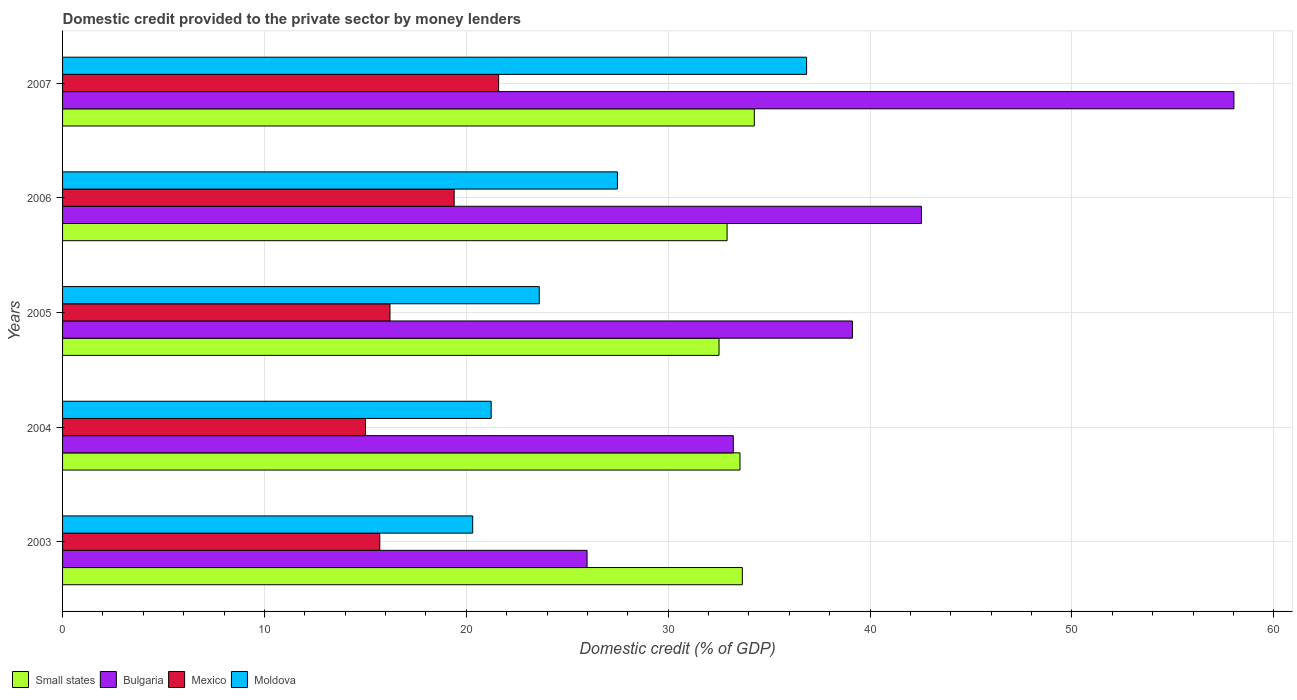How many different coloured bars are there?
Provide a succinct answer. 4. Are the number of bars on each tick of the Y-axis equal?
Your response must be concise. Yes. How many bars are there on the 5th tick from the top?
Ensure brevity in your answer.  4. What is the label of the 4th group of bars from the top?
Offer a terse response. 2004. What is the domestic credit provided to the private sector by money lenders in Moldova in 2004?
Ensure brevity in your answer.  21.23. Across all years, what is the maximum domestic credit provided to the private sector by money lenders in Moldova?
Keep it short and to the point. 36.86. Across all years, what is the minimum domestic credit provided to the private sector by money lenders in Mexico?
Offer a terse response. 15.01. In which year was the domestic credit provided to the private sector by money lenders in Mexico minimum?
Keep it short and to the point. 2004. What is the total domestic credit provided to the private sector by money lenders in Small states in the graph?
Offer a terse response. 166.93. What is the difference between the domestic credit provided to the private sector by money lenders in Bulgaria in 2003 and that in 2004?
Your answer should be very brief. -7.24. What is the difference between the domestic credit provided to the private sector by money lenders in Mexico in 2005 and the domestic credit provided to the private sector by money lenders in Bulgaria in 2003?
Keep it short and to the point. -9.76. What is the average domestic credit provided to the private sector by money lenders in Moldova per year?
Your answer should be compact. 25.9. In the year 2004, what is the difference between the domestic credit provided to the private sector by money lenders in Bulgaria and domestic credit provided to the private sector by money lenders in Small states?
Provide a short and direct response. -0.33. What is the ratio of the domestic credit provided to the private sector by money lenders in Bulgaria in 2004 to that in 2007?
Give a very brief answer. 0.57. Is the domestic credit provided to the private sector by money lenders in Bulgaria in 2003 less than that in 2007?
Provide a short and direct response. Yes. Is the difference between the domestic credit provided to the private sector by money lenders in Bulgaria in 2003 and 2006 greater than the difference between the domestic credit provided to the private sector by money lenders in Small states in 2003 and 2006?
Ensure brevity in your answer.  No. What is the difference between the highest and the second highest domestic credit provided to the private sector by money lenders in Bulgaria?
Offer a very short reply. 15.48. What is the difference between the highest and the lowest domestic credit provided to the private sector by money lenders in Bulgaria?
Offer a terse response. 32.04. In how many years, is the domestic credit provided to the private sector by money lenders in Moldova greater than the average domestic credit provided to the private sector by money lenders in Moldova taken over all years?
Your response must be concise. 2. Is it the case that in every year, the sum of the domestic credit provided to the private sector by money lenders in Mexico and domestic credit provided to the private sector by money lenders in Bulgaria is greater than the sum of domestic credit provided to the private sector by money lenders in Small states and domestic credit provided to the private sector by money lenders in Moldova?
Provide a succinct answer. No. What does the 3rd bar from the top in 2003 represents?
Make the answer very short. Bulgaria. What does the 2nd bar from the bottom in 2005 represents?
Your response must be concise. Bulgaria. Is it the case that in every year, the sum of the domestic credit provided to the private sector by money lenders in Bulgaria and domestic credit provided to the private sector by money lenders in Mexico is greater than the domestic credit provided to the private sector by money lenders in Moldova?
Keep it short and to the point. Yes. How many bars are there?
Give a very brief answer. 20. How many years are there in the graph?
Your answer should be very brief. 5. Does the graph contain any zero values?
Offer a terse response. No. Does the graph contain grids?
Make the answer very short. Yes. Where does the legend appear in the graph?
Provide a short and direct response. Bottom left. How many legend labels are there?
Your response must be concise. 4. How are the legend labels stacked?
Give a very brief answer. Horizontal. What is the title of the graph?
Give a very brief answer. Domestic credit provided to the private sector by money lenders. Does "World" appear as one of the legend labels in the graph?
Make the answer very short. No. What is the label or title of the X-axis?
Offer a very short reply. Domestic credit (% of GDP). What is the label or title of the Y-axis?
Your answer should be very brief. Years. What is the Domestic credit (% of GDP) of Small states in 2003?
Your response must be concise. 33.67. What is the Domestic credit (% of GDP) of Bulgaria in 2003?
Your answer should be very brief. 25.98. What is the Domestic credit (% of GDP) in Mexico in 2003?
Give a very brief answer. 15.71. What is the Domestic credit (% of GDP) in Moldova in 2003?
Provide a succinct answer. 20.32. What is the Domestic credit (% of GDP) in Small states in 2004?
Your answer should be compact. 33.56. What is the Domestic credit (% of GDP) in Bulgaria in 2004?
Provide a short and direct response. 33.23. What is the Domestic credit (% of GDP) of Mexico in 2004?
Ensure brevity in your answer.  15.01. What is the Domestic credit (% of GDP) in Moldova in 2004?
Keep it short and to the point. 21.23. What is the Domestic credit (% of GDP) of Small states in 2005?
Provide a succinct answer. 32.52. What is the Domestic credit (% of GDP) of Bulgaria in 2005?
Offer a terse response. 39.13. What is the Domestic credit (% of GDP) of Mexico in 2005?
Your answer should be very brief. 16.22. What is the Domestic credit (% of GDP) in Moldova in 2005?
Make the answer very short. 23.61. What is the Domestic credit (% of GDP) in Small states in 2006?
Offer a very short reply. 32.92. What is the Domestic credit (% of GDP) of Bulgaria in 2006?
Offer a terse response. 42.54. What is the Domestic credit (% of GDP) in Mexico in 2006?
Make the answer very short. 19.4. What is the Domestic credit (% of GDP) of Moldova in 2006?
Ensure brevity in your answer.  27.48. What is the Domestic credit (% of GDP) of Small states in 2007?
Keep it short and to the point. 34.27. What is the Domestic credit (% of GDP) in Bulgaria in 2007?
Ensure brevity in your answer.  58.02. What is the Domestic credit (% of GDP) of Mexico in 2007?
Make the answer very short. 21.6. What is the Domestic credit (% of GDP) in Moldova in 2007?
Ensure brevity in your answer.  36.86. Across all years, what is the maximum Domestic credit (% of GDP) of Small states?
Your answer should be very brief. 34.27. Across all years, what is the maximum Domestic credit (% of GDP) in Bulgaria?
Offer a terse response. 58.02. Across all years, what is the maximum Domestic credit (% of GDP) in Mexico?
Make the answer very short. 21.6. Across all years, what is the maximum Domestic credit (% of GDP) of Moldova?
Provide a succinct answer. 36.86. Across all years, what is the minimum Domestic credit (% of GDP) of Small states?
Offer a very short reply. 32.52. Across all years, what is the minimum Domestic credit (% of GDP) in Bulgaria?
Give a very brief answer. 25.98. Across all years, what is the minimum Domestic credit (% of GDP) of Mexico?
Make the answer very short. 15.01. Across all years, what is the minimum Domestic credit (% of GDP) of Moldova?
Provide a succinct answer. 20.32. What is the total Domestic credit (% of GDP) of Small states in the graph?
Your response must be concise. 166.93. What is the total Domestic credit (% of GDP) of Bulgaria in the graph?
Your answer should be very brief. 198.9. What is the total Domestic credit (% of GDP) of Mexico in the graph?
Your response must be concise. 87.94. What is the total Domestic credit (% of GDP) of Moldova in the graph?
Keep it short and to the point. 129.5. What is the difference between the Domestic credit (% of GDP) of Small states in 2003 and that in 2004?
Ensure brevity in your answer.  0.12. What is the difference between the Domestic credit (% of GDP) in Bulgaria in 2003 and that in 2004?
Your answer should be compact. -7.24. What is the difference between the Domestic credit (% of GDP) in Mexico in 2003 and that in 2004?
Your response must be concise. 0.71. What is the difference between the Domestic credit (% of GDP) of Moldova in 2003 and that in 2004?
Offer a terse response. -0.91. What is the difference between the Domestic credit (% of GDP) of Small states in 2003 and that in 2005?
Offer a terse response. 1.15. What is the difference between the Domestic credit (% of GDP) of Bulgaria in 2003 and that in 2005?
Your answer should be compact. -13.14. What is the difference between the Domestic credit (% of GDP) in Mexico in 2003 and that in 2005?
Offer a terse response. -0.5. What is the difference between the Domestic credit (% of GDP) in Moldova in 2003 and that in 2005?
Your response must be concise. -3.3. What is the difference between the Domestic credit (% of GDP) of Small states in 2003 and that in 2006?
Offer a very short reply. 0.76. What is the difference between the Domestic credit (% of GDP) in Bulgaria in 2003 and that in 2006?
Your answer should be compact. -16.56. What is the difference between the Domestic credit (% of GDP) of Mexico in 2003 and that in 2006?
Provide a short and direct response. -3.68. What is the difference between the Domestic credit (% of GDP) in Moldova in 2003 and that in 2006?
Provide a short and direct response. -7.17. What is the difference between the Domestic credit (% of GDP) in Small states in 2003 and that in 2007?
Keep it short and to the point. -0.59. What is the difference between the Domestic credit (% of GDP) in Bulgaria in 2003 and that in 2007?
Provide a short and direct response. -32.04. What is the difference between the Domestic credit (% of GDP) in Mexico in 2003 and that in 2007?
Offer a terse response. -5.89. What is the difference between the Domestic credit (% of GDP) in Moldova in 2003 and that in 2007?
Offer a terse response. -16.54. What is the difference between the Domestic credit (% of GDP) of Small states in 2004 and that in 2005?
Make the answer very short. 1.04. What is the difference between the Domestic credit (% of GDP) in Bulgaria in 2004 and that in 2005?
Make the answer very short. -5.9. What is the difference between the Domestic credit (% of GDP) of Mexico in 2004 and that in 2005?
Give a very brief answer. -1.21. What is the difference between the Domestic credit (% of GDP) of Moldova in 2004 and that in 2005?
Ensure brevity in your answer.  -2.38. What is the difference between the Domestic credit (% of GDP) of Small states in 2004 and that in 2006?
Keep it short and to the point. 0.64. What is the difference between the Domestic credit (% of GDP) in Bulgaria in 2004 and that in 2006?
Your answer should be very brief. -9.32. What is the difference between the Domestic credit (% of GDP) of Mexico in 2004 and that in 2006?
Your answer should be compact. -4.39. What is the difference between the Domestic credit (% of GDP) of Moldova in 2004 and that in 2006?
Give a very brief answer. -6.25. What is the difference between the Domestic credit (% of GDP) in Small states in 2004 and that in 2007?
Ensure brevity in your answer.  -0.71. What is the difference between the Domestic credit (% of GDP) of Bulgaria in 2004 and that in 2007?
Ensure brevity in your answer.  -24.8. What is the difference between the Domestic credit (% of GDP) of Mexico in 2004 and that in 2007?
Provide a short and direct response. -6.59. What is the difference between the Domestic credit (% of GDP) in Moldova in 2004 and that in 2007?
Provide a succinct answer. -15.62. What is the difference between the Domestic credit (% of GDP) in Small states in 2005 and that in 2006?
Give a very brief answer. -0.4. What is the difference between the Domestic credit (% of GDP) of Bulgaria in 2005 and that in 2006?
Provide a short and direct response. -3.42. What is the difference between the Domestic credit (% of GDP) in Mexico in 2005 and that in 2006?
Provide a succinct answer. -3.18. What is the difference between the Domestic credit (% of GDP) of Moldova in 2005 and that in 2006?
Keep it short and to the point. -3.87. What is the difference between the Domestic credit (% of GDP) of Small states in 2005 and that in 2007?
Keep it short and to the point. -1.75. What is the difference between the Domestic credit (% of GDP) in Bulgaria in 2005 and that in 2007?
Provide a short and direct response. -18.9. What is the difference between the Domestic credit (% of GDP) of Mexico in 2005 and that in 2007?
Make the answer very short. -5.38. What is the difference between the Domestic credit (% of GDP) in Moldova in 2005 and that in 2007?
Your answer should be compact. -13.24. What is the difference between the Domestic credit (% of GDP) of Small states in 2006 and that in 2007?
Your answer should be very brief. -1.35. What is the difference between the Domestic credit (% of GDP) in Bulgaria in 2006 and that in 2007?
Give a very brief answer. -15.48. What is the difference between the Domestic credit (% of GDP) in Mexico in 2006 and that in 2007?
Give a very brief answer. -2.2. What is the difference between the Domestic credit (% of GDP) in Moldova in 2006 and that in 2007?
Offer a very short reply. -9.37. What is the difference between the Domestic credit (% of GDP) in Small states in 2003 and the Domestic credit (% of GDP) in Bulgaria in 2004?
Your answer should be compact. 0.45. What is the difference between the Domestic credit (% of GDP) in Small states in 2003 and the Domestic credit (% of GDP) in Mexico in 2004?
Provide a succinct answer. 18.67. What is the difference between the Domestic credit (% of GDP) in Small states in 2003 and the Domestic credit (% of GDP) in Moldova in 2004?
Provide a short and direct response. 12.44. What is the difference between the Domestic credit (% of GDP) in Bulgaria in 2003 and the Domestic credit (% of GDP) in Mexico in 2004?
Your answer should be compact. 10.98. What is the difference between the Domestic credit (% of GDP) of Bulgaria in 2003 and the Domestic credit (% of GDP) of Moldova in 2004?
Provide a short and direct response. 4.75. What is the difference between the Domestic credit (% of GDP) in Mexico in 2003 and the Domestic credit (% of GDP) in Moldova in 2004?
Your answer should be very brief. -5.52. What is the difference between the Domestic credit (% of GDP) of Small states in 2003 and the Domestic credit (% of GDP) of Bulgaria in 2005?
Keep it short and to the point. -5.45. What is the difference between the Domestic credit (% of GDP) of Small states in 2003 and the Domestic credit (% of GDP) of Mexico in 2005?
Keep it short and to the point. 17.45. What is the difference between the Domestic credit (% of GDP) of Small states in 2003 and the Domestic credit (% of GDP) of Moldova in 2005?
Your answer should be compact. 10.06. What is the difference between the Domestic credit (% of GDP) of Bulgaria in 2003 and the Domestic credit (% of GDP) of Mexico in 2005?
Ensure brevity in your answer.  9.76. What is the difference between the Domestic credit (% of GDP) of Bulgaria in 2003 and the Domestic credit (% of GDP) of Moldova in 2005?
Provide a short and direct response. 2.37. What is the difference between the Domestic credit (% of GDP) of Mexico in 2003 and the Domestic credit (% of GDP) of Moldova in 2005?
Keep it short and to the point. -7.9. What is the difference between the Domestic credit (% of GDP) of Small states in 2003 and the Domestic credit (% of GDP) of Bulgaria in 2006?
Keep it short and to the point. -8.87. What is the difference between the Domestic credit (% of GDP) of Small states in 2003 and the Domestic credit (% of GDP) of Mexico in 2006?
Provide a succinct answer. 14.28. What is the difference between the Domestic credit (% of GDP) in Small states in 2003 and the Domestic credit (% of GDP) in Moldova in 2006?
Make the answer very short. 6.19. What is the difference between the Domestic credit (% of GDP) of Bulgaria in 2003 and the Domestic credit (% of GDP) of Mexico in 2006?
Offer a terse response. 6.58. What is the difference between the Domestic credit (% of GDP) of Bulgaria in 2003 and the Domestic credit (% of GDP) of Moldova in 2006?
Your answer should be very brief. -1.5. What is the difference between the Domestic credit (% of GDP) in Mexico in 2003 and the Domestic credit (% of GDP) in Moldova in 2006?
Your response must be concise. -11.77. What is the difference between the Domestic credit (% of GDP) in Small states in 2003 and the Domestic credit (% of GDP) in Bulgaria in 2007?
Offer a very short reply. -24.35. What is the difference between the Domestic credit (% of GDP) of Small states in 2003 and the Domestic credit (% of GDP) of Mexico in 2007?
Your answer should be compact. 12.07. What is the difference between the Domestic credit (% of GDP) in Small states in 2003 and the Domestic credit (% of GDP) in Moldova in 2007?
Keep it short and to the point. -3.18. What is the difference between the Domestic credit (% of GDP) of Bulgaria in 2003 and the Domestic credit (% of GDP) of Mexico in 2007?
Your response must be concise. 4.38. What is the difference between the Domestic credit (% of GDP) of Bulgaria in 2003 and the Domestic credit (% of GDP) of Moldova in 2007?
Offer a terse response. -10.87. What is the difference between the Domestic credit (% of GDP) of Mexico in 2003 and the Domestic credit (% of GDP) of Moldova in 2007?
Provide a succinct answer. -21.14. What is the difference between the Domestic credit (% of GDP) of Small states in 2004 and the Domestic credit (% of GDP) of Bulgaria in 2005?
Provide a short and direct response. -5.57. What is the difference between the Domestic credit (% of GDP) of Small states in 2004 and the Domestic credit (% of GDP) of Mexico in 2005?
Your answer should be very brief. 17.34. What is the difference between the Domestic credit (% of GDP) of Small states in 2004 and the Domestic credit (% of GDP) of Moldova in 2005?
Provide a succinct answer. 9.94. What is the difference between the Domestic credit (% of GDP) of Bulgaria in 2004 and the Domestic credit (% of GDP) of Mexico in 2005?
Ensure brevity in your answer.  17.01. What is the difference between the Domestic credit (% of GDP) in Bulgaria in 2004 and the Domestic credit (% of GDP) in Moldova in 2005?
Your answer should be very brief. 9.61. What is the difference between the Domestic credit (% of GDP) in Mexico in 2004 and the Domestic credit (% of GDP) in Moldova in 2005?
Provide a succinct answer. -8.61. What is the difference between the Domestic credit (% of GDP) of Small states in 2004 and the Domestic credit (% of GDP) of Bulgaria in 2006?
Offer a very short reply. -8.99. What is the difference between the Domestic credit (% of GDP) in Small states in 2004 and the Domestic credit (% of GDP) in Mexico in 2006?
Give a very brief answer. 14.16. What is the difference between the Domestic credit (% of GDP) of Small states in 2004 and the Domestic credit (% of GDP) of Moldova in 2006?
Your response must be concise. 6.07. What is the difference between the Domestic credit (% of GDP) of Bulgaria in 2004 and the Domestic credit (% of GDP) of Mexico in 2006?
Keep it short and to the point. 13.83. What is the difference between the Domestic credit (% of GDP) of Bulgaria in 2004 and the Domestic credit (% of GDP) of Moldova in 2006?
Provide a short and direct response. 5.74. What is the difference between the Domestic credit (% of GDP) in Mexico in 2004 and the Domestic credit (% of GDP) in Moldova in 2006?
Your response must be concise. -12.48. What is the difference between the Domestic credit (% of GDP) of Small states in 2004 and the Domestic credit (% of GDP) of Bulgaria in 2007?
Make the answer very short. -24.47. What is the difference between the Domestic credit (% of GDP) of Small states in 2004 and the Domestic credit (% of GDP) of Mexico in 2007?
Provide a succinct answer. 11.96. What is the difference between the Domestic credit (% of GDP) in Small states in 2004 and the Domestic credit (% of GDP) in Moldova in 2007?
Your answer should be compact. -3.3. What is the difference between the Domestic credit (% of GDP) in Bulgaria in 2004 and the Domestic credit (% of GDP) in Mexico in 2007?
Give a very brief answer. 11.62. What is the difference between the Domestic credit (% of GDP) in Bulgaria in 2004 and the Domestic credit (% of GDP) in Moldova in 2007?
Offer a terse response. -3.63. What is the difference between the Domestic credit (% of GDP) of Mexico in 2004 and the Domestic credit (% of GDP) of Moldova in 2007?
Provide a short and direct response. -21.85. What is the difference between the Domestic credit (% of GDP) in Small states in 2005 and the Domestic credit (% of GDP) in Bulgaria in 2006?
Make the answer very short. -10.03. What is the difference between the Domestic credit (% of GDP) of Small states in 2005 and the Domestic credit (% of GDP) of Mexico in 2006?
Provide a succinct answer. 13.12. What is the difference between the Domestic credit (% of GDP) in Small states in 2005 and the Domestic credit (% of GDP) in Moldova in 2006?
Give a very brief answer. 5.03. What is the difference between the Domestic credit (% of GDP) in Bulgaria in 2005 and the Domestic credit (% of GDP) in Mexico in 2006?
Provide a succinct answer. 19.73. What is the difference between the Domestic credit (% of GDP) of Bulgaria in 2005 and the Domestic credit (% of GDP) of Moldova in 2006?
Your answer should be very brief. 11.64. What is the difference between the Domestic credit (% of GDP) of Mexico in 2005 and the Domestic credit (% of GDP) of Moldova in 2006?
Provide a short and direct response. -11.27. What is the difference between the Domestic credit (% of GDP) of Small states in 2005 and the Domestic credit (% of GDP) of Bulgaria in 2007?
Give a very brief answer. -25.51. What is the difference between the Domestic credit (% of GDP) of Small states in 2005 and the Domestic credit (% of GDP) of Mexico in 2007?
Your answer should be very brief. 10.92. What is the difference between the Domestic credit (% of GDP) in Small states in 2005 and the Domestic credit (% of GDP) in Moldova in 2007?
Offer a terse response. -4.34. What is the difference between the Domestic credit (% of GDP) in Bulgaria in 2005 and the Domestic credit (% of GDP) in Mexico in 2007?
Provide a short and direct response. 17.53. What is the difference between the Domestic credit (% of GDP) of Bulgaria in 2005 and the Domestic credit (% of GDP) of Moldova in 2007?
Your answer should be very brief. 2.27. What is the difference between the Domestic credit (% of GDP) in Mexico in 2005 and the Domestic credit (% of GDP) in Moldova in 2007?
Provide a short and direct response. -20.64. What is the difference between the Domestic credit (% of GDP) of Small states in 2006 and the Domestic credit (% of GDP) of Bulgaria in 2007?
Provide a succinct answer. -25.11. What is the difference between the Domestic credit (% of GDP) of Small states in 2006 and the Domestic credit (% of GDP) of Mexico in 2007?
Offer a terse response. 11.32. What is the difference between the Domestic credit (% of GDP) in Small states in 2006 and the Domestic credit (% of GDP) in Moldova in 2007?
Provide a short and direct response. -3.94. What is the difference between the Domestic credit (% of GDP) of Bulgaria in 2006 and the Domestic credit (% of GDP) of Mexico in 2007?
Provide a succinct answer. 20.94. What is the difference between the Domestic credit (% of GDP) of Bulgaria in 2006 and the Domestic credit (% of GDP) of Moldova in 2007?
Your answer should be very brief. 5.69. What is the difference between the Domestic credit (% of GDP) of Mexico in 2006 and the Domestic credit (% of GDP) of Moldova in 2007?
Offer a terse response. -17.46. What is the average Domestic credit (% of GDP) of Small states per year?
Keep it short and to the point. 33.39. What is the average Domestic credit (% of GDP) of Bulgaria per year?
Offer a terse response. 39.78. What is the average Domestic credit (% of GDP) of Mexico per year?
Provide a short and direct response. 17.59. What is the average Domestic credit (% of GDP) in Moldova per year?
Keep it short and to the point. 25.9. In the year 2003, what is the difference between the Domestic credit (% of GDP) in Small states and Domestic credit (% of GDP) in Bulgaria?
Your answer should be compact. 7.69. In the year 2003, what is the difference between the Domestic credit (% of GDP) of Small states and Domestic credit (% of GDP) of Mexico?
Offer a terse response. 17.96. In the year 2003, what is the difference between the Domestic credit (% of GDP) of Small states and Domestic credit (% of GDP) of Moldova?
Provide a short and direct response. 13.36. In the year 2003, what is the difference between the Domestic credit (% of GDP) in Bulgaria and Domestic credit (% of GDP) in Mexico?
Ensure brevity in your answer.  10.27. In the year 2003, what is the difference between the Domestic credit (% of GDP) of Bulgaria and Domestic credit (% of GDP) of Moldova?
Your answer should be very brief. 5.67. In the year 2003, what is the difference between the Domestic credit (% of GDP) in Mexico and Domestic credit (% of GDP) in Moldova?
Offer a terse response. -4.6. In the year 2004, what is the difference between the Domestic credit (% of GDP) of Small states and Domestic credit (% of GDP) of Bulgaria?
Keep it short and to the point. 0.33. In the year 2004, what is the difference between the Domestic credit (% of GDP) of Small states and Domestic credit (% of GDP) of Mexico?
Keep it short and to the point. 18.55. In the year 2004, what is the difference between the Domestic credit (% of GDP) in Small states and Domestic credit (% of GDP) in Moldova?
Ensure brevity in your answer.  12.33. In the year 2004, what is the difference between the Domestic credit (% of GDP) in Bulgaria and Domestic credit (% of GDP) in Mexico?
Your response must be concise. 18.22. In the year 2004, what is the difference between the Domestic credit (% of GDP) of Bulgaria and Domestic credit (% of GDP) of Moldova?
Your answer should be compact. 11.99. In the year 2004, what is the difference between the Domestic credit (% of GDP) in Mexico and Domestic credit (% of GDP) in Moldova?
Your answer should be compact. -6.22. In the year 2005, what is the difference between the Domestic credit (% of GDP) of Small states and Domestic credit (% of GDP) of Bulgaria?
Your response must be concise. -6.61. In the year 2005, what is the difference between the Domestic credit (% of GDP) in Small states and Domestic credit (% of GDP) in Mexico?
Keep it short and to the point. 16.3. In the year 2005, what is the difference between the Domestic credit (% of GDP) of Small states and Domestic credit (% of GDP) of Moldova?
Make the answer very short. 8.9. In the year 2005, what is the difference between the Domestic credit (% of GDP) of Bulgaria and Domestic credit (% of GDP) of Mexico?
Your answer should be compact. 22.91. In the year 2005, what is the difference between the Domestic credit (% of GDP) in Bulgaria and Domestic credit (% of GDP) in Moldova?
Your answer should be compact. 15.51. In the year 2005, what is the difference between the Domestic credit (% of GDP) of Mexico and Domestic credit (% of GDP) of Moldova?
Provide a succinct answer. -7.39. In the year 2006, what is the difference between the Domestic credit (% of GDP) of Small states and Domestic credit (% of GDP) of Bulgaria?
Offer a terse response. -9.63. In the year 2006, what is the difference between the Domestic credit (% of GDP) of Small states and Domestic credit (% of GDP) of Mexico?
Make the answer very short. 13.52. In the year 2006, what is the difference between the Domestic credit (% of GDP) in Small states and Domestic credit (% of GDP) in Moldova?
Make the answer very short. 5.43. In the year 2006, what is the difference between the Domestic credit (% of GDP) in Bulgaria and Domestic credit (% of GDP) in Mexico?
Make the answer very short. 23.15. In the year 2006, what is the difference between the Domestic credit (% of GDP) in Bulgaria and Domestic credit (% of GDP) in Moldova?
Offer a very short reply. 15.06. In the year 2006, what is the difference between the Domestic credit (% of GDP) of Mexico and Domestic credit (% of GDP) of Moldova?
Offer a very short reply. -8.09. In the year 2007, what is the difference between the Domestic credit (% of GDP) of Small states and Domestic credit (% of GDP) of Bulgaria?
Make the answer very short. -23.76. In the year 2007, what is the difference between the Domestic credit (% of GDP) of Small states and Domestic credit (% of GDP) of Mexico?
Make the answer very short. 12.67. In the year 2007, what is the difference between the Domestic credit (% of GDP) of Small states and Domestic credit (% of GDP) of Moldova?
Make the answer very short. -2.59. In the year 2007, what is the difference between the Domestic credit (% of GDP) in Bulgaria and Domestic credit (% of GDP) in Mexico?
Offer a very short reply. 36.42. In the year 2007, what is the difference between the Domestic credit (% of GDP) of Bulgaria and Domestic credit (% of GDP) of Moldova?
Keep it short and to the point. 21.17. In the year 2007, what is the difference between the Domestic credit (% of GDP) in Mexico and Domestic credit (% of GDP) in Moldova?
Provide a succinct answer. -15.26. What is the ratio of the Domestic credit (% of GDP) in Small states in 2003 to that in 2004?
Provide a short and direct response. 1. What is the ratio of the Domestic credit (% of GDP) of Bulgaria in 2003 to that in 2004?
Offer a terse response. 0.78. What is the ratio of the Domestic credit (% of GDP) in Mexico in 2003 to that in 2004?
Provide a succinct answer. 1.05. What is the ratio of the Domestic credit (% of GDP) in Moldova in 2003 to that in 2004?
Your answer should be very brief. 0.96. What is the ratio of the Domestic credit (% of GDP) of Small states in 2003 to that in 2005?
Your response must be concise. 1.04. What is the ratio of the Domestic credit (% of GDP) of Bulgaria in 2003 to that in 2005?
Your answer should be compact. 0.66. What is the ratio of the Domestic credit (% of GDP) of Mexico in 2003 to that in 2005?
Keep it short and to the point. 0.97. What is the ratio of the Domestic credit (% of GDP) of Moldova in 2003 to that in 2005?
Provide a short and direct response. 0.86. What is the ratio of the Domestic credit (% of GDP) in Small states in 2003 to that in 2006?
Your response must be concise. 1.02. What is the ratio of the Domestic credit (% of GDP) in Bulgaria in 2003 to that in 2006?
Ensure brevity in your answer.  0.61. What is the ratio of the Domestic credit (% of GDP) in Mexico in 2003 to that in 2006?
Make the answer very short. 0.81. What is the ratio of the Domestic credit (% of GDP) in Moldova in 2003 to that in 2006?
Your answer should be compact. 0.74. What is the ratio of the Domestic credit (% of GDP) of Small states in 2003 to that in 2007?
Your response must be concise. 0.98. What is the ratio of the Domestic credit (% of GDP) in Bulgaria in 2003 to that in 2007?
Offer a terse response. 0.45. What is the ratio of the Domestic credit (% of GDP) in Mexico in 2003 to that in 2007?
Your answer should be very brief. 0.73. What is the ratio of the Domestic credit (% of GDP) of Moldova in 2003 to that in 2007?
Provide a short and direct response. 0.55. What is the ratio of the Domestic credit (% of GDP) of Small states in 2004 to that in 2005?
Keep it short and to the point. 1.03. What is the ratio of the Domestic credit (% of GDP) in Bulgaria in 2004 to that in 2005?
Your answer should be compact. 0.85. What is the ratio of the Domestic credit (% of GDP) of Mexico in 2004 to that in 2005?
Keep it short and to the point. 0.93. What is the ratio of the Domestic credit (% of GDP) of Moldova in 2004 to that in 2005?
Give a very brief answer. 0.9. What is the ratio of the Domestic credit (% of GDP) of Small states in 2004 to that in 2006?
Make the answer very short. 1.02. What is the ratio of the Domestic credit (% of GDP) of Bulgaria in 2004 to that in 2006?
Give a very brief answer. 0.78. What is the ratio of the Domestic credit (% of GDP) in Mexico in 2004 to that in 2006?
Keep it short and to the point. 0.77. What is the ratio of the Domestic credit (% of GDP) in Moldova in 2004 to that in 2006?
Provide a short and direct response. 0.77. What is the ratio of the Domestic credit (% of GDP) in Small states in 2004 to that in 2007?
Your answer should be compact. 0.98. What is the ratio of the Domestic credit (% of GDP) of Bulgaria in 2004 to that in 2007?
Your answer should be very brief. 0.57. What is the ratio of the Domestic credit (% of GDP) in Mexico in 2004 to that in 2007?
Your answer should be compact. 0.69. What is the ratio of the Domestic credit (% of GDP) in Moldova in 2004 to that in 2007?
Give a very brief answer. 0.58. What is the ratio of the Domestic credit (% of GDP) of Small states in 2005 to that in 2006?
Offer a very short reply. 0.99. What is the ratio of the Domestic credit (% of GDP) of Bulgaria in 2005 to that in 2006?
Ensure brevity in your answer.  0.92. What is the ratio of the Domestic credit (% of GDP) of Mexico in 2005 to that in 2006?
Provide a succinct answer. 0.84. What is the ratio of the Domestic credit (% of GDP) of Moldova in 2005 to that in 2006?
Make the answer very short. 0.86. What is the ratio of the Domestic credit (% of GDP) of Small states in 2005 to that in 2007?
Give a very brief answer. 0.95. What is the ratio of the Domestic credit (% of GDP) in Bulgaria in 2005 to that in 2007?
Offer a terse response. 0.67. What is the ratio of the Domestic credit (% of GDP) in Mexico in 2005 to that in 2007?
Provide a short and direct response. 0.75. What is the ratio of the Domestic credit (% of GDP) in Moldova in 2005 to that in 2007?
Provide a succinct answer. 0.64. What is the ratio of the Domestic credit (% of GDP) of Small states in 2006 to that in 2007?
Offer a terse response. 0.96. What is the ratio of the Domestic credit (% of GDP) of Bulgaria in 2006 to that in 2007?
Provide a short and direct response. 0.73. What is the ratio of the Domestic credit (% of GDP) in Mexico in 2006 to that in 2007?
Keep it short and to the point. 0.9. What is the ratio of the Domestic credit (% of GDP) of Moldova in 2006 to that in 2007?
Make the answer very short. 0.75. What is the difference between the highest and the second highest Domestic credit (% of GDP) in Small states?
Your answer should be very brief. 0.59. What is the difference between the highest and the second highest Domestic credit (% of GDP) in Bulgaria?
Give a very brief answer. 15.48. What is the difference between the highest and the second highest Domestic credit (% of GDP) of Mexico?
Make the answer very short. 2.2. What is the difference between the highest and the second highest Domestic credit (% of GDP) of Moldova?
Your answer should be very brief. 9.37. What is the difference between the highest and the lowest Domestic credit (% of GDP) in Small states?
Your answer should be compact. 1.75. What is the difference between the highest and the lowest Domestic credit (% of GDP) of Bulgaria?
Give a very brief answer. 32.04. What is the difference between the highest and the lowest Domestic credit (% of GDP) in Mexico?
Offer a terse response. 6.59. What is the difference between the highest and the lowest Domestic credit (% of GDP) in Moldova?
Provide a short and direct response. 16.54. 